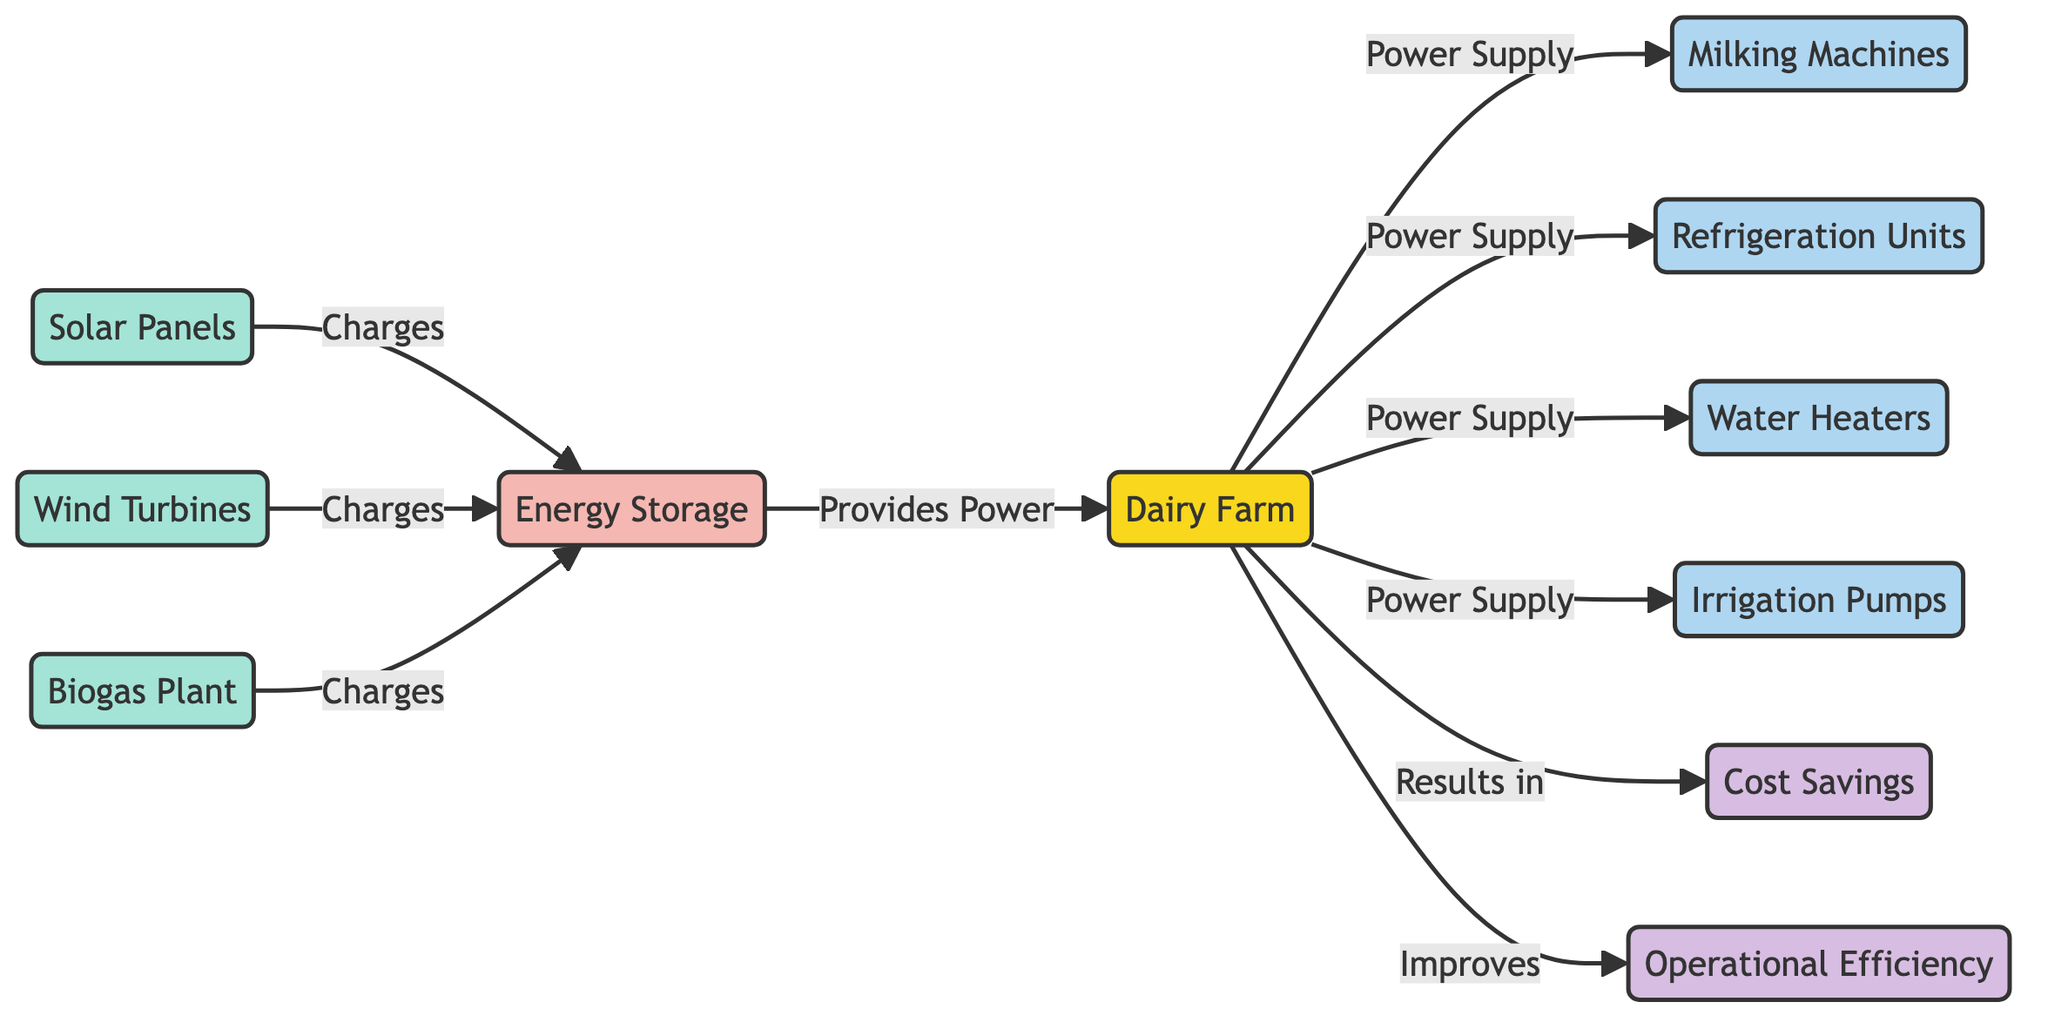What is the main energy source for the dairy farm? The main energy sources listed in the diagram that provide energy to the dairy farm include solar panels, wind turbines, and a biogas plant. All these sources connect to the energy storage, which then supplies power to the dairy farm.
Answer: Solar Panels, Wind Turbines, Biogas Plant How many pieces of equipment are connected to the dairy farm? The diagram lists four pieces of equipment connected to the dairy farm, which are the milking machines, refrigeration units, water heaters, and irrigation pumps. Each of these has a power supply line coming from the dairy farm.
Answer: 4 What do solar panels do in this diagram? Solar panels charge the energy storage, which is an intermediary component that collects energy before distributing it to the dairy farm. This relationship is explicitly shown by the directed edge from solar panels to energy storage labeled "Charges."
Answer: Charges Which renewable energy source contributes to operational efficiency? The diagram indicates that renewable energy usage improves operational efficiency. Thus, the connection between renewable energy usage and operational efficiency highlights this contribution.
Answer: Renewable Energy Usage What is the outcome of renewable energy usage highlighted in the diagram? The outcomes highlighted for renewable energy usage include cost savings and improved operational efficiency. Both outcomes are directly connected via directed edges from renewable energy usage.
Answer: Cost Savings, Operational Efficiency How does energy storage impact the dairy farm? Energy storage provides power to the dairy farm, allowing the farm to utilize energy from various renewable sources. The arrow from energy storage to the dairy farm labeled "Provides Power" indicates this critical relationship.
Answer: Provides Power What is the total number of nodes in this diagram? The diagram has 11 nodes in total, including the dairy farm, energy sources, infrastructure, equipment, and outcomes. This is counted from each distinct entity represented within the diagram.
Answer: 11 How many energy sources are visualized in the diagram? The diagram visualizes three energy sources: solar panels, wind turbines, and a biogas plant. These are represented as specific nodes that charge the energy storage.
Answer: 3 What results from renewable energy usage according to the diagram? According to the diagram, the use of renewable energy results in cost savings and improved operational efficiency. This is clearly stated through directional arrows leading from renewable energy usage to each outcome.
Answer: Cost Savings, Operational Efficiency 